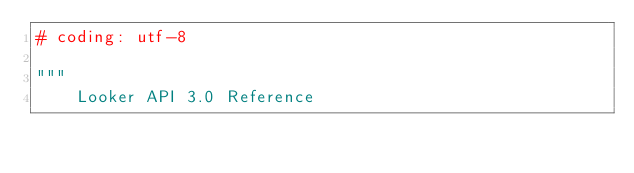<code> <loc_0><loc_0><loc_500><loc_500><_Python_># coding: utf-8

"""
    Looker API 3.0 Reference
</code> 